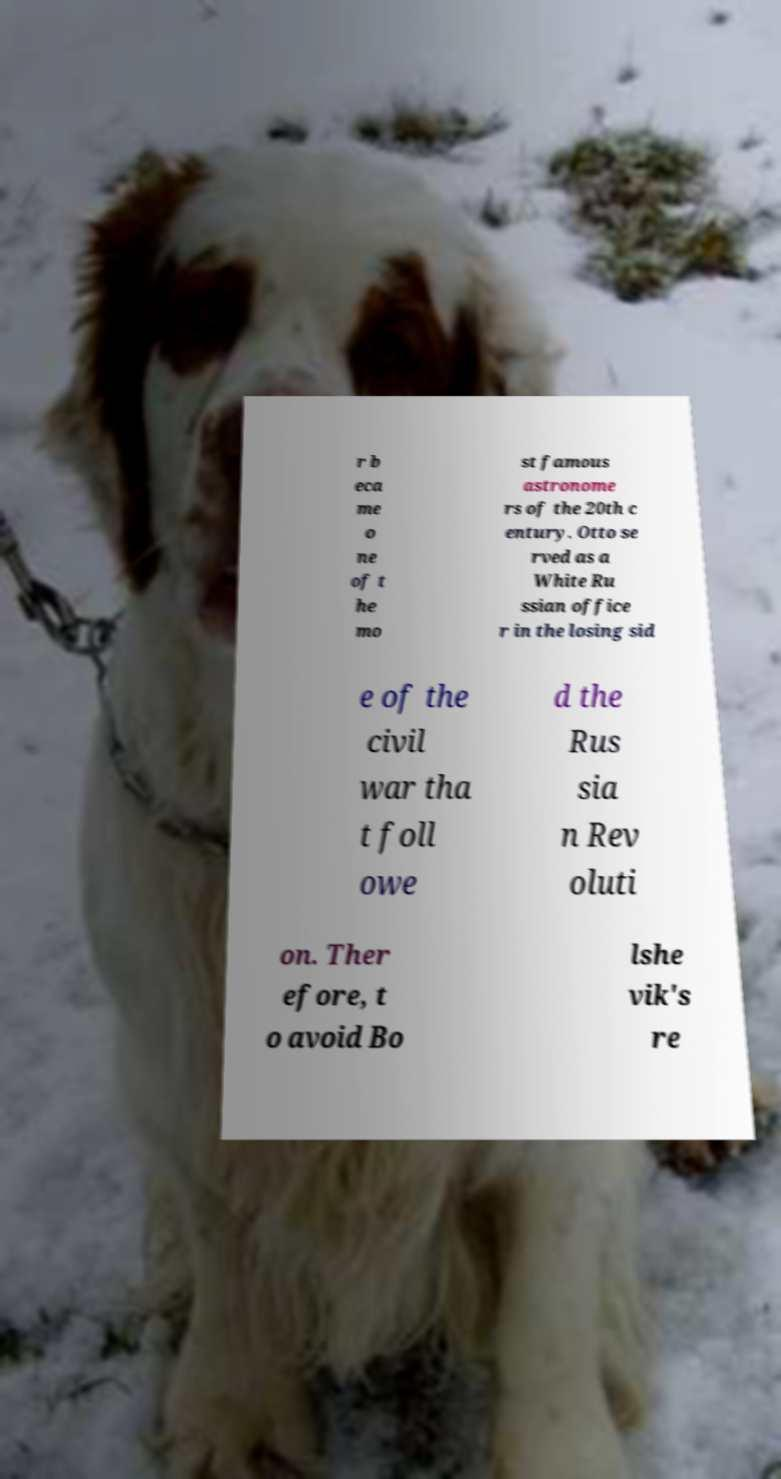Can you read and provide the text displayed in the image?This photo seems to have some interesting text. Can you extract and type it out for me? r b eca me o ne of t he mo st famous astronome rs of the 20th c entury. Otto se rved as a White Ru ssian office r in the losing sid e of the civil war tha t foll owe d the Rus sia n Rev oluti on. Ther efore, t o avoid Bo lshe vik's re 